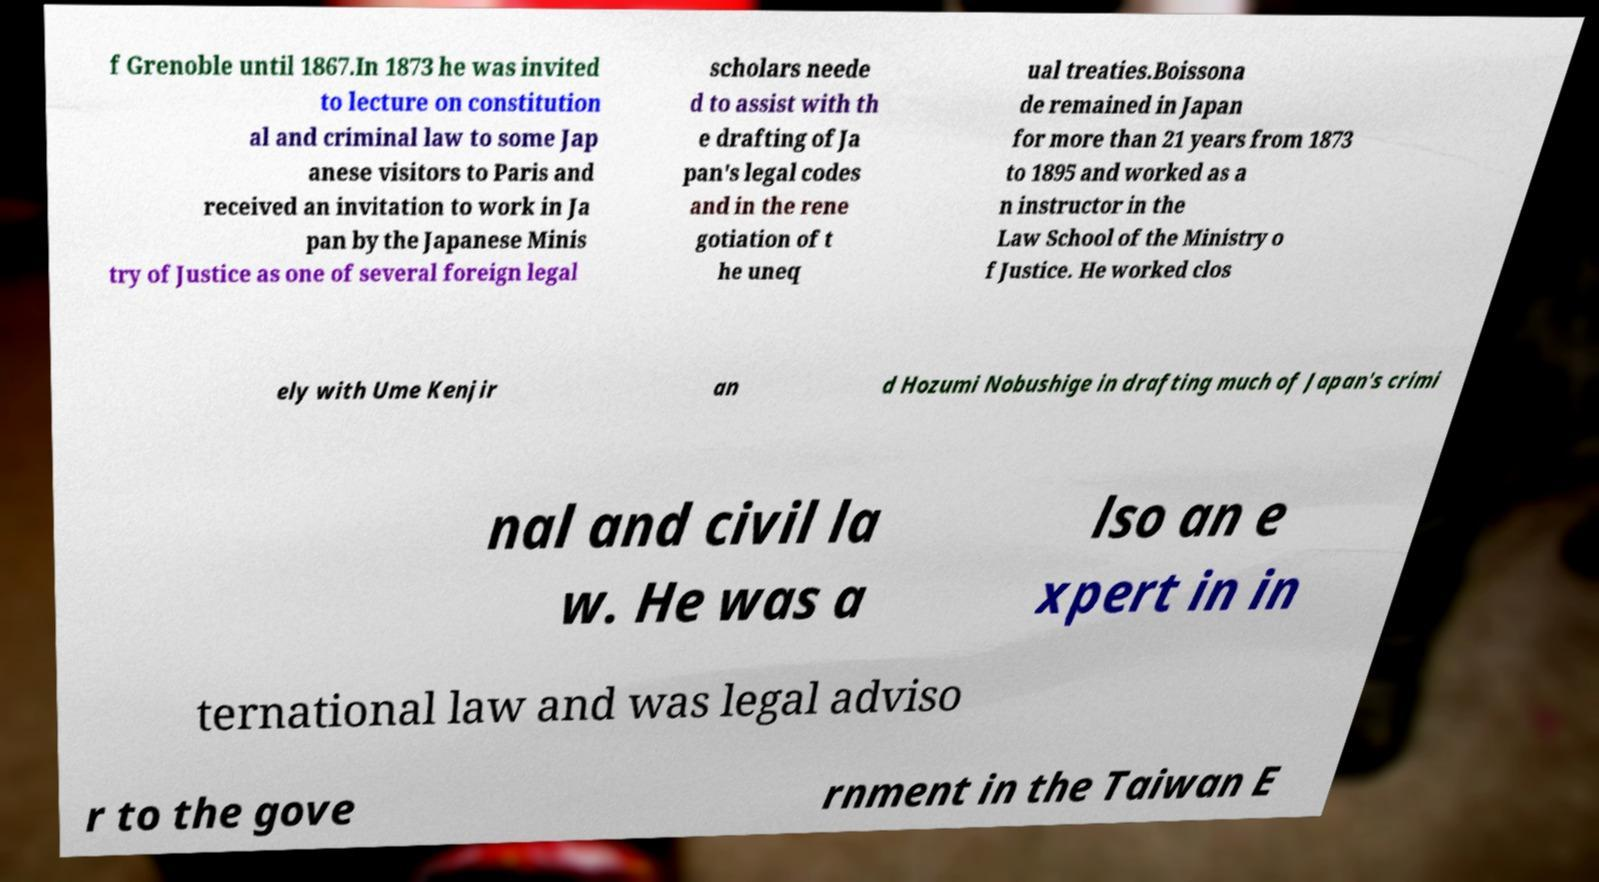There's text embedded in this image that I need extracted. Can you transcribe it verbatim? f Grenoble until 1867.In 1873 he was invited to lecture on constitution al and criminal law to some Jap anese visitors to Paris and received an invitation to work in Ja pan by the Japanese Minis try of Justice as one of several foreign legal scholars neede d to assist with th e drafting of Ja pan's legal codes and in the rene gotiation of t he uneq ual treaties.Boissona de remained in Japan for more than 21 years from 1873 to 1895 and worked as a n instructor in the Law School of the Ministry o f Justice. He worked clos ely with Ume Kenjir an d Hozumi Nobushige in drafting much of Japan's crimi nal and civil la w. He was a lso an e xpert in in ternational law and was legal adviso r to the gove rnment in the Taiwan E 